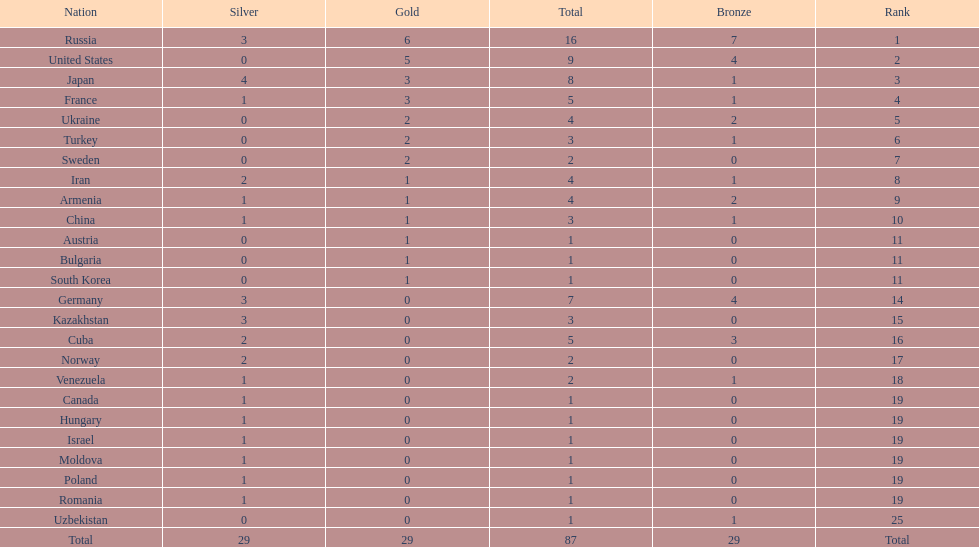Would you be able to parse every entry in this table? {'header': ['Nation', 'Silver', 'Gold', 'Total', 'Bronze', 'Rank'], 'rows': [['Russia', '3', '6', '16', '7', '1'], ['United States', '0', '5', '9', '4', '2'], ['Japan', '4', '3', '8', '1', '3'], ['France', '1', '3', '5', '1', '4'], ['Ukraine', '0', '2', '4', '2', '5'], ['Turkey', '0', '2', '3', '1', '6'], ['Sweden', '0', '2', '2', '0', '7'], ['Iran', '2', '1', '4', '1', '8'], ['Armenia', '1', '1', '4', '2', '9'], ['China', '1', '1', '3', '1', '10'], ['Austria', '0', '1', '1', '0', '11'], ['Bulgaria', '0', '1', '1', '0', '11'], ['South Korea', '0', '1', '1', '0', '11'], ['Germany', '3', '0', '7', '4', '14'], ['Kazakhstan', '3', '0', '3', '0', '15'], ['Cuba', '2', '0', '5', '3', '16'], ['Norway', '2', '0', '2', '0', '17'], ['Venezuela', '1', '0', '2', '1', '18'], ['Canada', '1', '0', '1', '0', '19'], ['Hungary', '1', '0', '1', '0', '19'], ['Israel', '1', '0', '1', '0', '19'], ['Moldova', '1', '0', '1', '0', '19'], ['Poland', '1', '0', '1', '0', '19'], ['Romania', '1', '0', '1', '0', '19'], ['Uzbekistan', '0', '0', '1', '1', '25'], ['Total', '29', '29', '87', '29', 'Total']]} Japan and france each won how many gold medals? 3. 